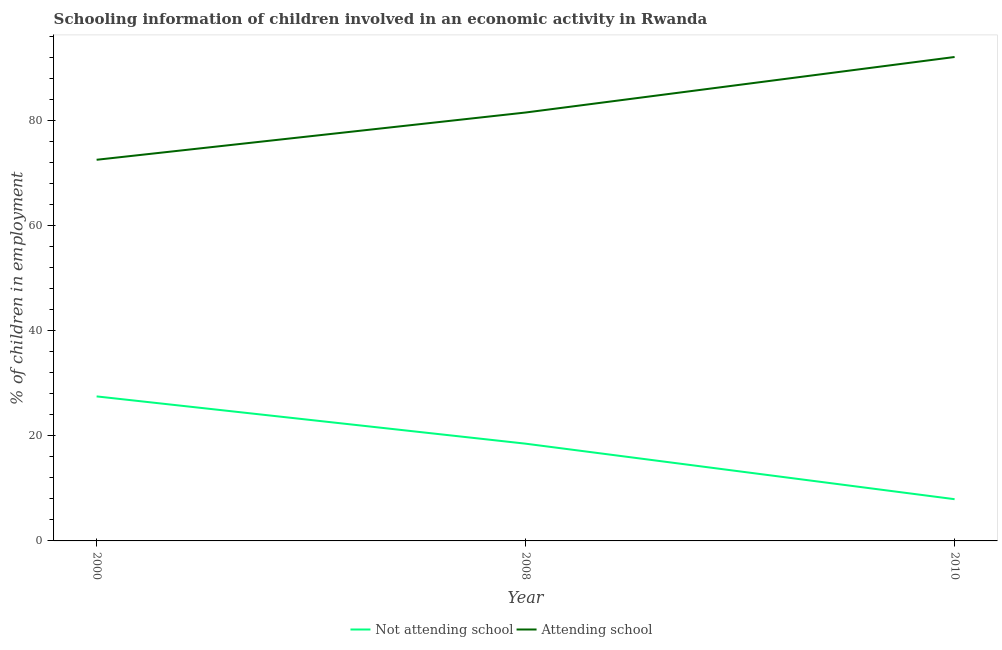Is the number of lines equal to the number of legend labels?
Make the answer very short. Yes. What is the percentage of employed children who are not attending school in 2008?
Provide a short and direct response. 18.5. Across all years, what is the maximum percentage of employed children who are not attending school?
Provide a short and direct response. 27.49. Across all years, what is the minimum percentage of employed children who are not attending school?
Provide a short and direct response. 7.94. In which year was the percentage of employed children who are attending school maximum?
Make the answer very short. 2010. What is the total percentage of employed children who are attending school in the graph?
Keep it short and to the point. 246.07. What is the difference between the percentage of employed children who are attending school in 2008 and that in 2010?
Ensure brevity in your answer.  -10.56. What is the difference between the percentage of employed children who are attending school in 2008 and the percentage of employed children who are not attending school in 2000?
Offer a very short reply. 54.01. What is the average percentage of employed children who are attending school per year?
Keep it short and to the point. 82.02. In the year 2000, what is the difference between the percentage of employed children who are not attending school and percentage of employed children who are attending school?
Your response must be concise. -45.02. In how many years, is the percentage of employed children who are not attending school greater than 48 %?
Provide a succinct answer. 0. What is the ratio of the percentage of employed children who are not attending school in 2008 to that in 2010?
Your answer should be compact. 2.33. What is the difference between the highest and the second highest percentage of employed children who are attending school?
Give a very brief answer. 10.56. What is the difference between the highest and the lowest percentage of employed children who are attending school?
Your answer should be compact. 19.55. In how many years, is the percentage of employed children who are not attending school greater than the average percentage of employed children who are not attending school taken over all years?
Give a very brief answer. 2. Is the sum of the percentage of employed children who are attending school in 2000 and 2008 greater than the maximum percentage of employed children who are not attending school across all years?
Make the answer very short. Yes. What is the difference between two consecutive major ticks on the Y-axis?
Give a very brief answer. 20. Are the values on the major ticks of Y-axis written in scientific E-notation?
Provide a short and direct response. No. Does the graph contain any zero values?
Your response must be concise. No. Does the graph contain grids?
Provide a succinct answer. No. Where does the legend appear in the graph?
Provide a short and direct response. Bottom center. How many legend labels are there?
Provide a short and direct response. 2. What is the title of the graph?
Give a very brief answer. Schooling information of children involved in an economic activity in Rwanda. What is the label or title of the X-axis?
Offer a very short reply. Year. What is the label or title of the Y-axis?
Give a very brief answer. % of children in employment. What is the % of children in employment in Not attending school in 2000?
Your answer should be compact. 27.49. What is the % of children in employment of Attending school in 2000?
Provide a short and direct response. 72.51. What is the % of children in employment of Not attending school in 2008?
Make the answer very short. 18.5. What is the % of children in employment of Attending school in 2008?
Your response must be concise. 81.5. What is the % of children in employment of Not attending school in 2010?
Provide a short and direct response. 7.94. What is the % of children in employment in Attending school in 2010?
Offer a very short reply. 92.06. Across all years, what is the maximum % of children in employment in Not attending school?
Your answer should be compact. 27.49. Across all years, what is the maximum % of children in employment of Attending school?
Offer a terse response. 92.06. Across all years, what is the minimum % of children in employment of Not attending school?
Your answer should be very brief. 7.94. Across all years, what is the minimum % of children in employment of Attending school?
Offer a very short reply. 72.51. What is the total % of children in employment in Not attending school in the graph?
Keep it short and to the point. 53.93. What is the total % of children in employment of Attending school in the graph?
Keep it short and to the point. 246.07. What is the difference between the % of children in employment of Not attending school in 2000 and that in 2008?
Keep it short and to the point. 8.99. What is the difference between the % of children in employment of Attending school in 2000 and that in 2008?
Offer a terse response. -8.99. What is the difference between the % of children in employment of Not attending school in 2000 and that in 2010?
Provide a short and direct response. 19.55. What is the difference between the % of children in employment in Attending school in 2000 and that in 2010?
Offer a very short reply. -19.55. What is the difference between the % of children in employment in Not attending school in 2008 and that in 2010?
Your answer should be very brief. 10.56. What is the difference between the % of children in employment of Attending school in 2008 and that in 2010?
Your answer should be compact. -10.56. What is the difference between the % of children in employment of Not attending school in 2000 and the % of children in employment of Attending school in 2008?
Your answer should be very brief. -54.01. What is the difference between the % of children in employment of Not attending school in 2000 and the % of children in employment of Attending school in 2010?
Provide a succinct answer. -64.57. What is the difference between the % of children in employment in Not attending school in 2008 and the % of children in employment in Attending school in 2010?
Offer a very short reply. -73.56. What is the average % of children in employment of Not attending school per year?
Offer a terse response. 17.98. What is the average % of children in employment in Attending school per year?
Your answer should be compact. 82.02. In the year 2000, what is the difference between the % of children in employment of Not attending school and % of children in employment of Attending school?
Offer a very short reply. -45.02. In the year 2008, what is the difference between the % of children in employment in Not attending school and % of children in employment in Attending school?
Make the answer very short. -63. In the year 2010, what is the difference between the % of children in employment of Not attending school and % of children in employment of Attending school?
Keep it short and to the point. -84.12. What is the ratio of the % of children in employment of Not attending school in 2000 to that in 2008?
Keep it short and to the point. 1.49. What is the ratio of the % of children in employment of Attending school in 2000 to that in 2008?
Provide a succinct answer. 0.89. What is the ratio of the % of children in employment in Not attending school in 2000 to that in 2010?
Make the answer very short. 3.46. What is the ratio of the % of children in employment of Attending school in 2000 to that in 2010?
Your answer should be very brief. 0.79. What is the ratio of the % of children in employment in Not attending school in 2008 to that in 2010?
Ensure brevity in your answer.  2.33. What is the ratio of the % of children in employment in Attending school in 2008 to that in 2010?
Give a very brief answer. 0.89. What is the difference between the highest and the second highest % of children in employment in Not attending school?
Ensure brevity in your answer.  8.99. What is the difference between the highest and the second highest % of children in employment of Attending school?
Provide a short and direct response. 10.56. What is the difference between the highest and the lowest % of children in employment of Not attending school?
Ensure brevity in your answer.  19.55. What is the difference between the highest and the lowest % of children in employment in Attending school?
Your response must be concise. 19.55. 